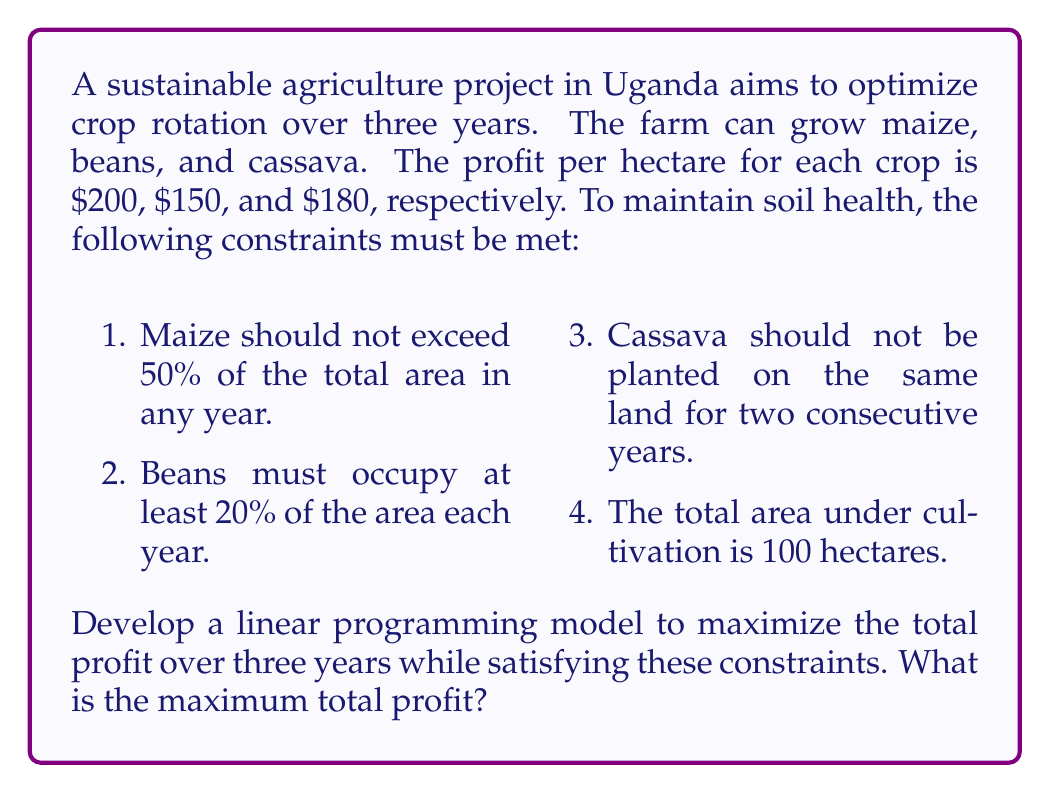Teach me how to tackle this problem. Let's approach this step-by-step:

1) Define variables:
   Let $x_{ij}$ be the area (in hectares) of crop $i$ in year $j$
   Where $i = 1$ (maize), $2$ (beans), $3$ (cassava)
   And $j = 1, 2, 3$ (years)

2) Objective function:
   Maximize $Z = 200(x_{11} + x_{12} + x_{13}) + 150(x_{21} + x_{22} + x_{23}) + 180(x_{31} + x_{32} + x_{33})$

3) Constraints:
   a) Area constraint for each year:
      $x_{1j} + x_{2j} + x_{3j} = 100$ for $j = 1, 2, 3$

   b) Maize constraint:
      $x_{1j} \leq 50$ for $j = 1, 2, 3$

   c) Beans constraint:
      $x_{2j} \geq 20$ for $j = 1, 2, 3$

   d) Cassava constraint:
      $x_{31} + x_{32} \leq 100$
      $x_{32} + x_{33} \leq 100$

   e) Non-negativity:
      $x_{ij} \geq 0$ for all $i$ and $j$

4) Solve using linear programming software or simplex method. The optimal solution is:

   Year 1: 50 ha maize, 20 ha beans, 30 ha cassava
   Year 2: 50 ha maize, 50 ha beans, 0 ha cassava
   Year 3: 50 ha maize, 20 ha beans, 30 ha cassava

5) Calculate the total profit:
   $Z = 200(50 + 50 + 50) + 150(20 + 50 + 20) + 180(30 + 0 + 30)$
   $Z = 30,000 + 13,500 + 10,800 = 54,300$

Therefore, the maximum total profit over three years is $54,300.
Answer: $54,300 